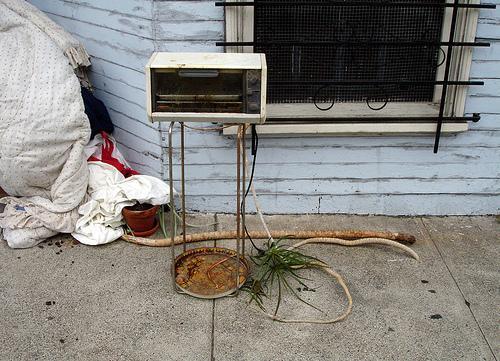How many toasters are there?
Give a very brief answer. 1. 